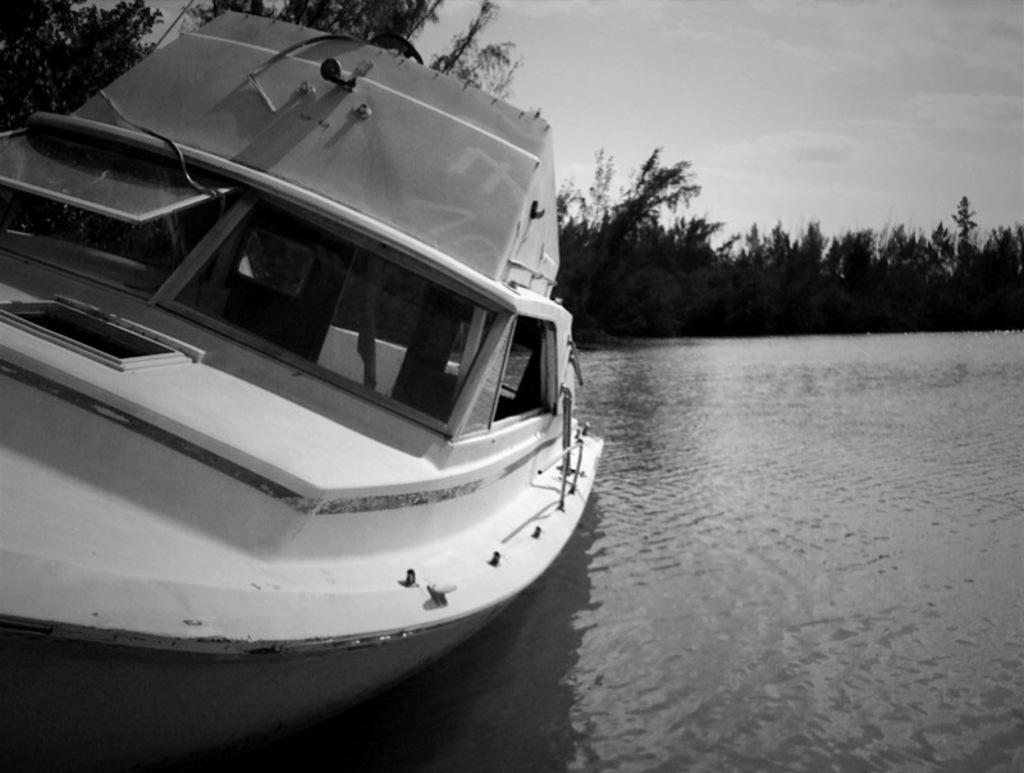Describe this image in one or two sentences. In this image on the left side I can see a boat on the water. In the background, I can see the trees and clouds in the sky. I can also see the image is in black and white color. 